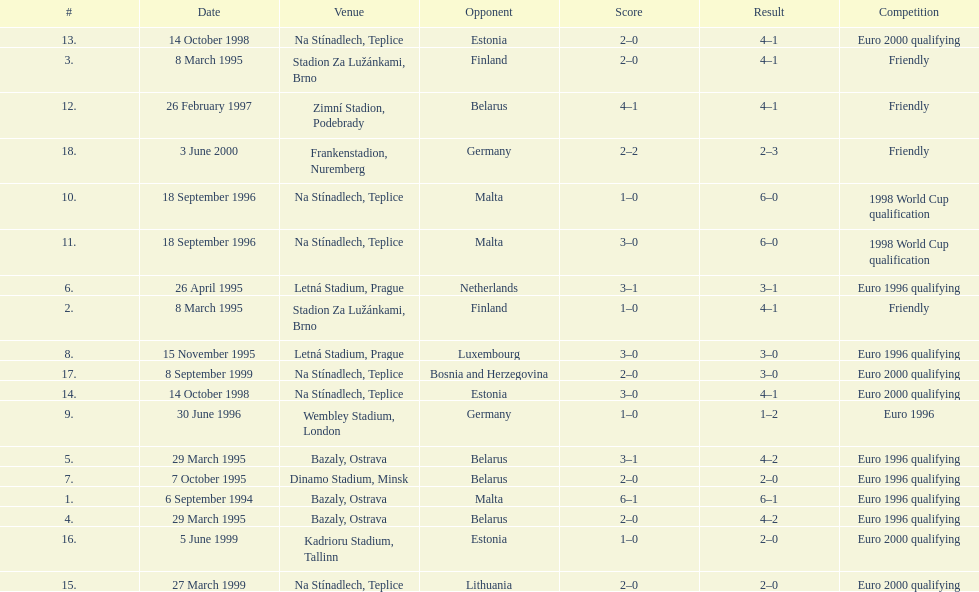List the opponent in which the result was the least out of all the results. Germany. 